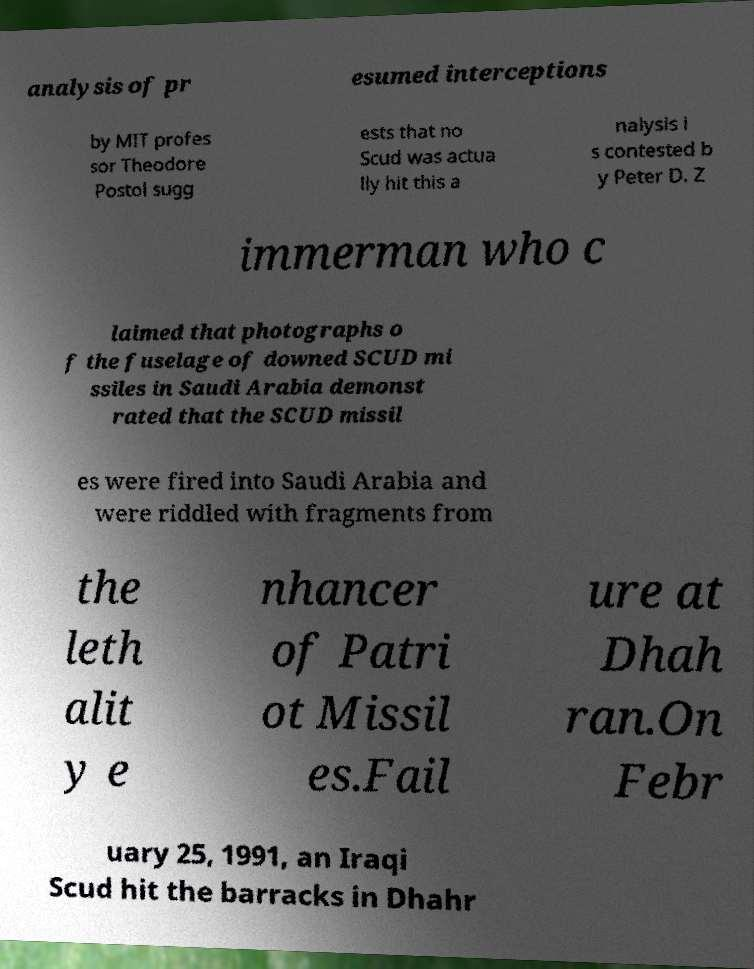There's text embedded in this image that I need extracted. Can you transcribe it verbatim? analysis of pr esumed interceptions by MIT profes sor Theodore Postol sugg ests that no Scud was actua lly hit this a nalysis i s contested b y Peter D. Z immerman who c laimed that photographs o f the fuselage of downed SCUD mi ssiles in Saudi Arabia demonst rated that the SCUD missil es were fired into Saudi Arabia and were riddled with fragments from the leth alit y e nhancer of Patri ot Missil es.Fail ure at Dhah ran.On Febr uary 25, 1991, an Iraqi Scud hit the barracks in Dhahr 